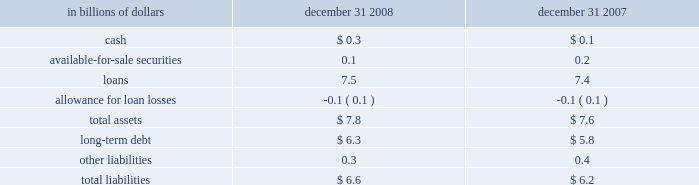On-balance sheet securitizations the company engages in on-balance sheet securitizations .
These are securitizations that do not qualify for sales treatment ; thus , the assets remain on the company 2019s balance sheet .
The table presents the carrying amounts and classification of consolidated assets and liabilities transferred in transactions from the consumer credit card , student loan , mortgage and auto businesses , accounted for as secured borrowings : in billions of dollars december 31 , december 31 .
All assets are restricted from being sold or pledged as collateral .
The cash flows from these assets are the only source used to pay down the associated liabilities , which are non-recourse to the company 2019s general assets .
Citi-administered asset-backed commercial paper conduits the company is active in the asset-backed commercial paper conduit business as administrator of several multi-seller commercial paper conduits , and also as a service provider to single-seller and other commercial paper conduits sponsored by third parties .
The multi-seller commercial paper conduits are designed to provide the company 2019s customers access to low-cost funding in the commercial paper markets .
The conduits purchase assets from or provide financing facilities to customers and are funded by issuing commercial paper to third-party investors .
The conduits generally do not purchase assets originated by the company .
The funding of the conduit is facilitated by the liquidity support and credit enhancements provided by the company and by certain third parties .
As administrator to the conduits , the company is responsible for selecting and structuring of assets purchased or financed by the conduits , making decisions regarding the funding of the conduits , including determining the tenor and other features of the commercial paper issued , monitoring the quality and performance of the conduits 2019 assets , and facilitating the operations and cash flows of the conduits .
In return , the company earns structuring fees from clients for individual transactions and earns an administration fee from the conduit , which is equal to the income from client program and liquidity fees of the conduit after payment of interest costs and other fees .
This administration fee is fairly stable , since most risks and rewards of the underlying assets are passed back to the customers and , once the asset pricing is negotiated , most ongoing income , costs and fees are relatively stable as a percentage of the conduit 2019s size .
The conduits administered by the company do not generally invest in liquid securities that are formally rated by third parties .
The assets are privately negotiated and structured transactions that are designed to be held by the conduit , rather than actively traded and sold .
The yield earned by the conduit on each asset is generally tied to the rate on the commercial paper issued by the conduit , thus passing interest rate risk to the client .
Each asset purchased by the conduit is structured with transaction-specific credit enhancement features provided by the third-party seller , including over- collateralization , cash and excess spread collateral accounts , direct recourse or third-party guarantees .
These credit enhancements are sized with the objective of approximating a credit rating of a or above , based on the company 2019s internal risk ratings .
Substantially all of the funding of the conduits is in the form of short- term commercial paper .
As of december 31 , 2008 , the weighted average life of the commercial paper issued was approximately 37 days .
In addition , the conduits have issued subordinate loss notes and equity with a notional amount of approximately $ 80 million and varying remaining tenors ranging from six months to seven years .
The primary credit enhancement provided to the conduit investors is in the form of transaction-specific credit enhancement described above .
In addition , there are two additional forms of credit enhancement that protect the commercial paper investors from defaulting assets .
First , the subordinate loss notes issued by each conduit absorb any credit losses up to their full notional amount .
It is expected that the subordinate loss notes issued by each conduit are sufficient to absorb a majority of the expected losses from each conduit , thereby making the single investor in the subordinate loss note the primary beneficiary under fin 46 ( r ) .
Second , each conduit has obtained a letter of credit from the company , which is generally 8-10% ( 8-10 % ) of the conduit 2019s assets .
The letters of credit provided by the company total approximately $ 5.8 billion and are included in the company 2019s maximum exposure to loss .
The net result across all multi-seller conduits administered by the company is that , in the event of defaulted assets in excess of the transaction-specific credit enhancement described above , any losses in each conduit are allocated in the following order : 2022 subordinate loss note holders 2022 the company 2022 the commercial paper investors the company , along with third parties , also provides the conduits with two forms of liquidity agreements that are used to provide funding to the conduits in the event of a market disruption , among other events .
Each asset of the conduit is supported by a transaction-specific liquidity facility in the form of an asset purchase agreement ( apa ) .
Under the apa , the company has agreed to purchase non-defaulted eligible receivables from the conduit at par .
Any assets purchased under the apa are subject to increased pricing .
The apa is not designed to provide credit support to the conduit , as it generally does not permit the purchase of defaulted or impaired assets and generally reprices the assets purchased to consider potential increased credit risk .
The apa covers all assets in the conduits and is considered in the company 2019s maximum exposure to loss .
In addition , the company provides the conduits with program-wide liquidity in the form of short-term lending commitments .
Under these commitments , the company has agreed to lend to the conduits in the event of a short-term disruption in the commercial paper market , subject to specified conditions .
The total notional exposure under the program-wide liquidity agreement is $ 11.3 billion and is considered in the company 2019s maximum exposure to loss .
The company receives fees for providing both types of liquidity agreement and considers these fees to be on fair market terms. .
At december 312008 what was the debt to the equity ratio? 
Computations: (7.8 / 6.6)
Answer: 1.18182. On-balance sheet securitizations the company engages in on-balance sheet securitizations .
These are securitizations that do not qualify for sales treatment ; thus , the assets remain on the company 2019s balance sheet .
The table presents the carrying amounts and classification of consolidated assets and liabilities transferred in transactions from the consumer credit card , student loan , mortgage and auto businesses , accounted for as secured borrowings : in billions of dollars december 31 , december 31 .
All assets are restricted from being sold or pledged as collateral .
The cash flows from these assets are the only source used to pay down the associated liabilities , which are non-recourse to the company 2019s general assets .
Citi-administered asset-backed commercial paper conduits the company is active in the asset-backed commercial paper conduit business as administrator of several multi-seller commercial paper conduits , and also as a service provider to single-seller and other commercial paper conduits sponsored by third parties .
The multi-seller commercial paper conduits are designed to provide the company 2019s customers access to low-cost funding in the commercial paper markets .
The conduits purchase assets from or provide financing facilities to customers and are funded by issuing commercial paper to third-party investors .
The conduits generally do not purchase assets originated by the company .
The funding of the conduit is facilitated by the liquidity support and credit enhancements provided by the company and by certain third parties .
As administrator to the conduits , the company is responsible for selecting and structuring of assets purchased or financed by the conduits , making decisions regarding the funding of the conduits , including determining the tenor and other features of the commercial paper issued , monitoring the quality and performance of the conduits 2019 assets , and facilitating the operations and cash flows of the conduits .
In return , the company earns structuring fees from clients for individual transactions and earns an administration fee from the conduit , which is equal to the income from client program and liquidity fees of the conduit after payment of interest costs and other fees .
This administration fee is fairly stable , since most risks and rewards of the underlying assets are passed back to the customers and , once the asset pricing is negotiated , most ongoing income , costs and fees are relatively stable as a percentage of the conduit 2019s size .
The conduits administered by the company do not generally invest in liquid securities that are formally rated by third parties .
The assets are privately negotiated and structured transactions that are designed to be held by the conduit , rather than actively traded and sold .
The yield earned by the conduit on each asset is generally tied to the rate on the commercial paper issued by the conduit , thus passing interest rate risk to the client .
Each asset purchased by the conduit is structured with transaction-specific credit enhancement features provided by the third-party seller , including over- collateralization , cash and excess spread collateral accounts , direct recourse or third-party guarantees .
These credit enhancements are sized with the objective of approximating a credit rating of a or above , based on the company 2019s internal risk ratings .
Substantially all of the funding of the conduits is in the form of short- term commercial paper .
As of december 31 , 2008 , the weighted average life of the commercial paper issued was approximately 37 days .
In addition , the conduits have issued subordinate loss notes and equity with a notional amount of approximately $ 80 million and varying remaining tenors ranging from six months to seven years .
The primary credit enhancement provided to the conduit investors is in the form of transaction-specific credit enhancement described above .
In addition , there are two additional forms of credit enhancement that protect the commercial paper investors from defaulting assets .
First , the subordinate loss notes issued by each conduit absorb any credit losses up to their full notional amount .
It is expected that the subordinate loss notes issued by each conduit are sufficient to absorb a majority of the expected losses from each conduit , thereby making the single investor in the subordinate loss note the primary beneficiary under fin 46 ( r ) .
Second , each conduit has obtained a letter of credit from the company , which is generally 8-10% ( 8-10 % ) of the conduit 2019s assets .
The letters of credit provided by the company total approximately $ 5.8 billion and are included in the company 2019s maximum exposure to loss .
The net result across all multi-seller conduits administered by the company is that , in the event of defaulted assets in excess of the transaction-specific credit enhancement described above , any losses in each conduit are allocated in the following order : 2022 subordinate loss note holders 2022 the company 2022 the commercial paper investors the company , along with third parties , also provides the conduits with two forms of liquidity agreements that are used to provide funding to the conduits in the event of a market disruption , among other events .
Each asset of the conduit is supported by a transaction-specific liquidity facility in the form of an asset purchase agreement ( apa ) .
Under the apa , the company has agreed to purchase non-defaulted eligible receivables from the conduit at par .
Any assets purchased under the apa are subject to increased pricing .
The apa is not designed to provide credit support to the conduit , as it generally does not permit the purchase of defaulted or impaired assets and generally reprices the assets purchased to consider potential increased credit risk .
The apa covers all assets in the conduits and is considered in the company 2019s maximum exposure to loss .
In addition , the company provides the conduits with program-wide liquidity in the form of short-term lending commitments .
Under these commitments , the company has agreed to lend to the conduits in the event of a short-term disruption in the commercial paper market , subject to specified conditions .
The total notional exposure under the program-wide liquidity agreement is $ 11.3 billion and is considered in the company 2019s maximum exposure to loss .
The company receives fees for providing both types of liquidity agreement and considers these fees to be on fair market terms. .
What was the change in billions of the cash between 2007 and 2008? 
Computations: (0.3 - 0.1)
Answer: 0.2. 